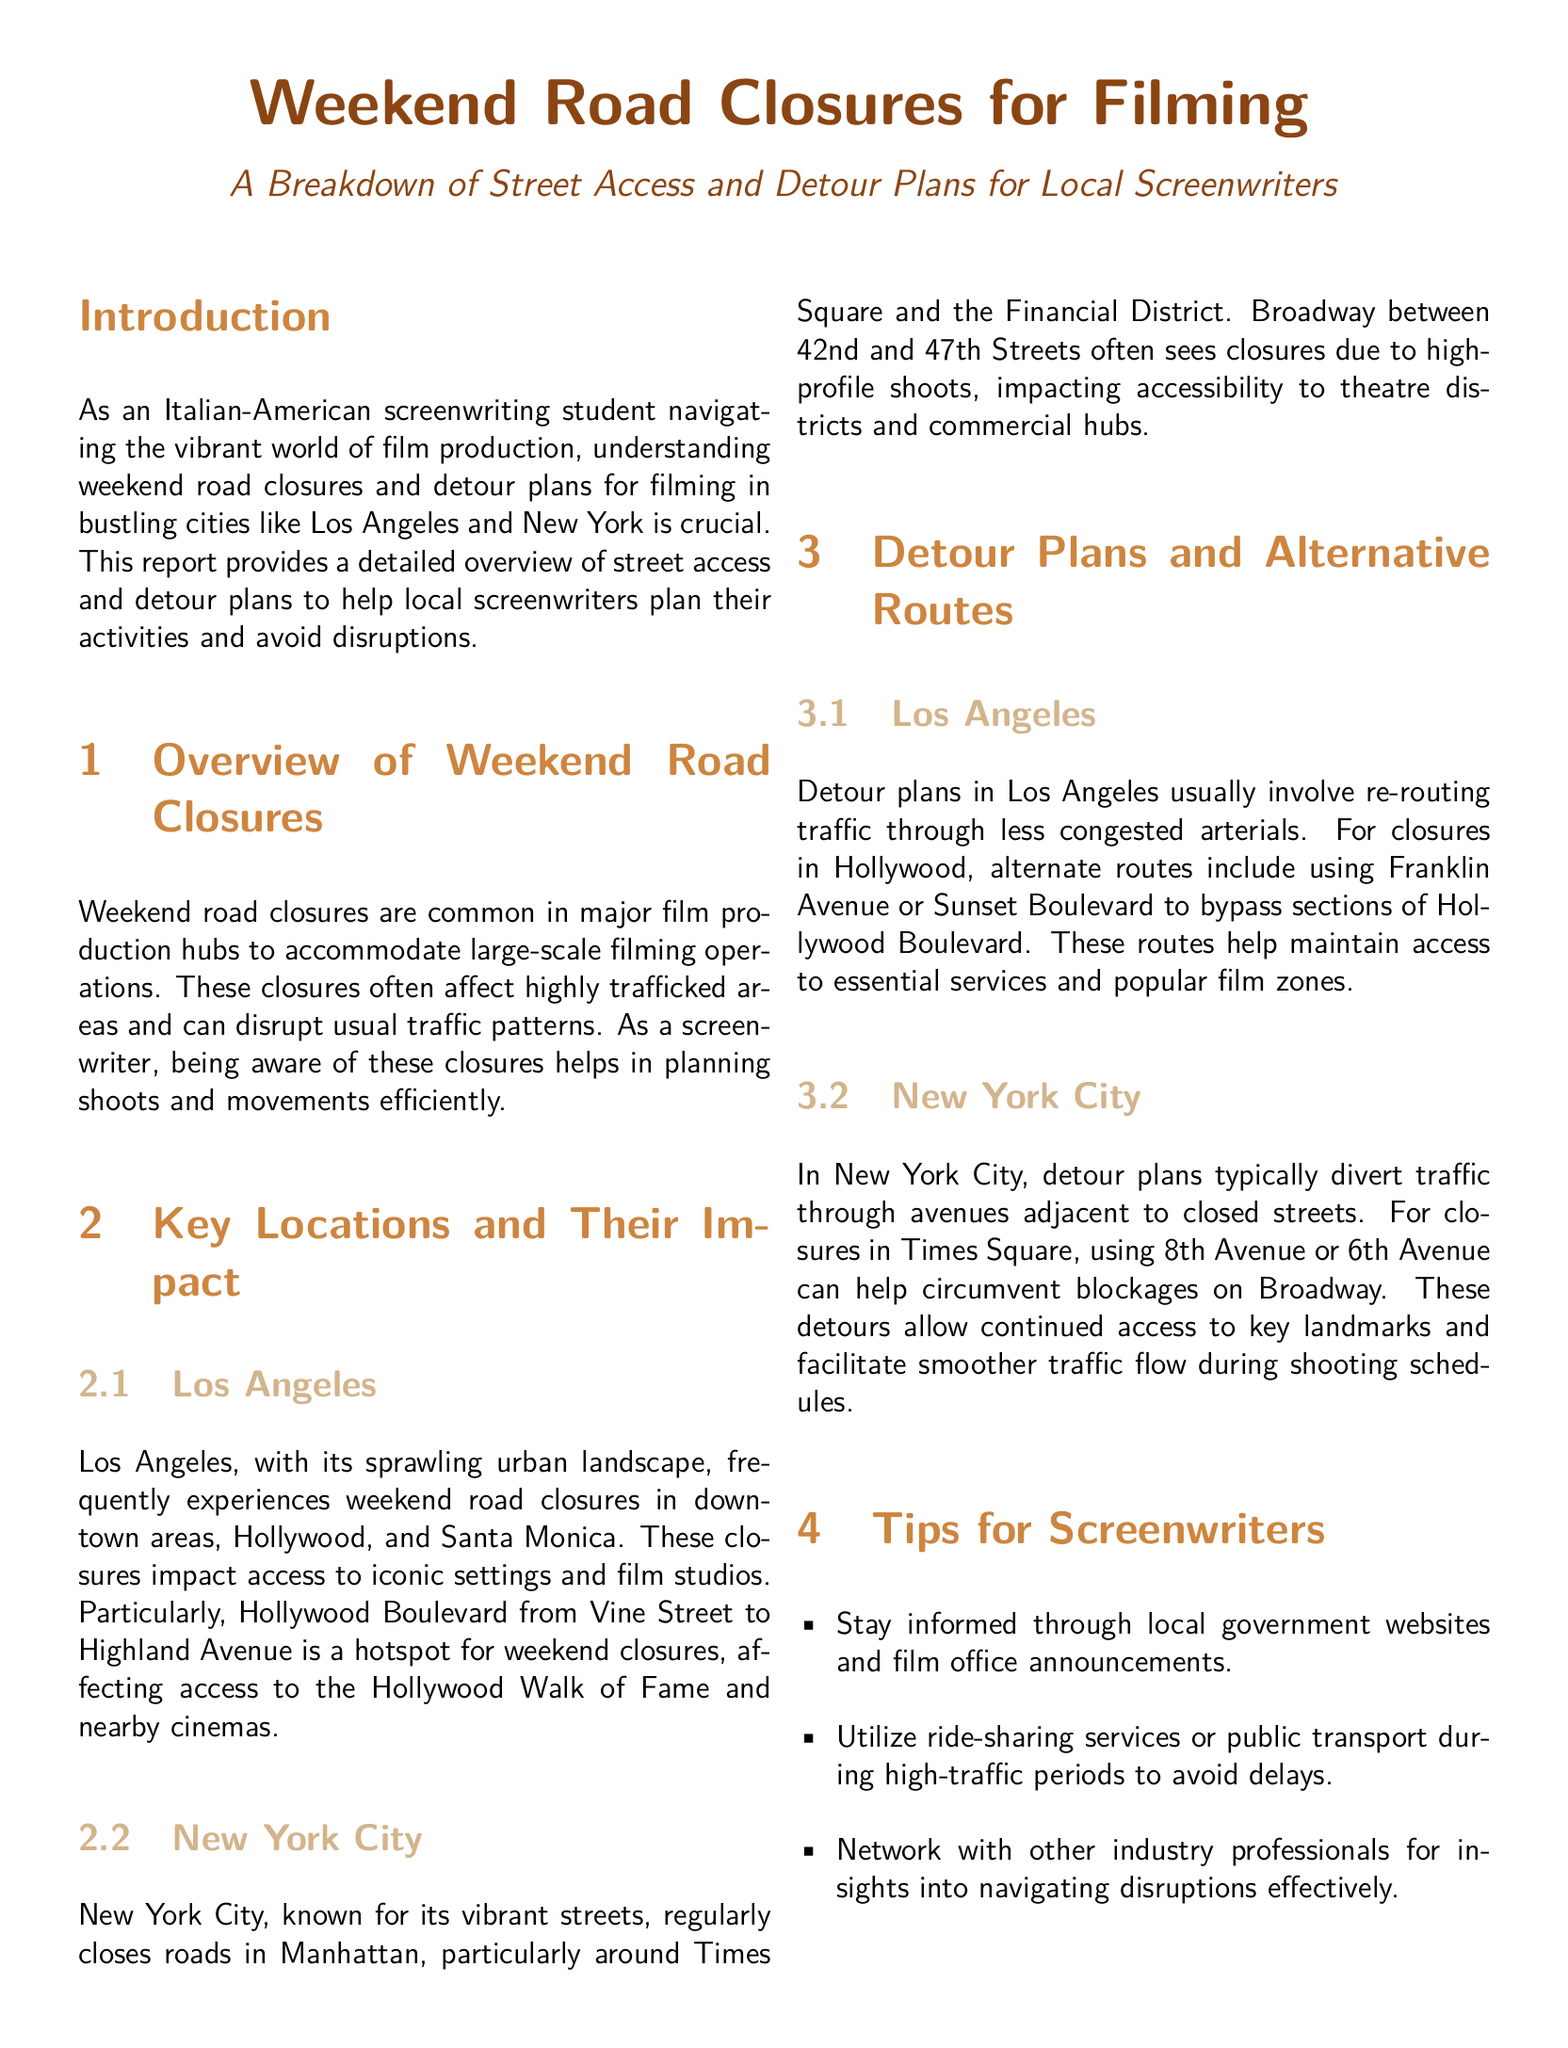What is the main focus of the report? The report focuses on providing information about road closures related to filming and detour plans for screenwriters.
Answer: Weekend road closures for filming Which areas in Los Angeles are mentioned as having frequent road closures? The document specifies certain areas in Los Angeles prone to road closures, highlighting their significance.
Answer: Downtown, Hollywood, Santa Monica What iconic location is affected by closures on Hollywood Boulevard? The report identifies a famous landmark impacted by the closures on Hollywood Boulevard.
Answer: Hollywood Walk of Fame Which street in New York City often experiences closures due to high-profile shoots? The document refers to a specific street in New York City that is commonly closed during filming activities.
Answer: Broadway What alternative routes are suggested for Hollywood closures? The report provides alternate routes to help navigate closures, ensuring continued access to popular areas.
Answer: Franklin Avenue or Sunset Boulevard What is a key tip for screenwriters to avoid delays? The report offers practical advice for screenwriters to efficiently manage their travel plans during road closures.
Answer: Utilize ride-sharing services or public transport What is the purpose of the detour plans mentioned in the document? The reasoning for implementing detour plans focuses on maintaining ease of access during road blockages.
Answer: To maintain access Which department is mentioned as a resource for traffic information in Los Angeles? The document specifies a particular department that offers information relevant to local traffic conditions.
Answer: LADOT 